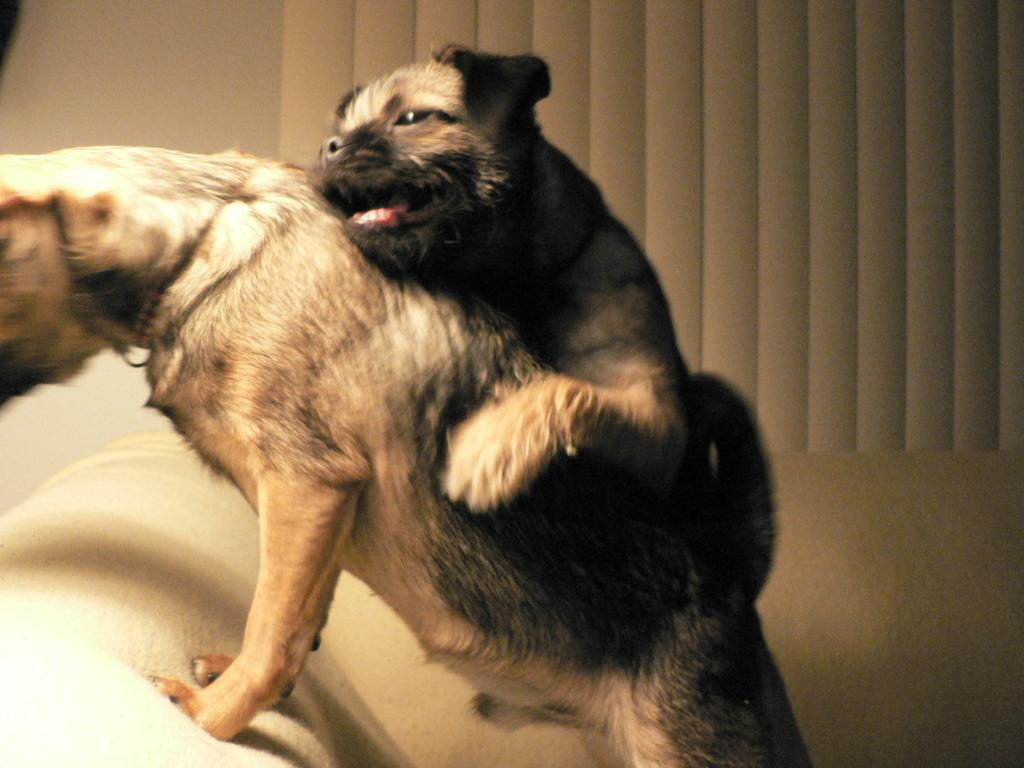Where was the image taken? The image was taken indoors. What is the main subject of the image? There are two dogs in the center of the image. What are the dogs doing in the image? The dogs are on a couch. What can be seen in the background of the image? There is an object in the background that appears to be a wall. What type of trousers can be seen hanging on the wall in the image? There are no trousers visible in the image; the background object appears to be a wall. How many boats are docked at the harbor in the image? There is no harbor or boats present in the image; it features two dogs on a couch indoors. 